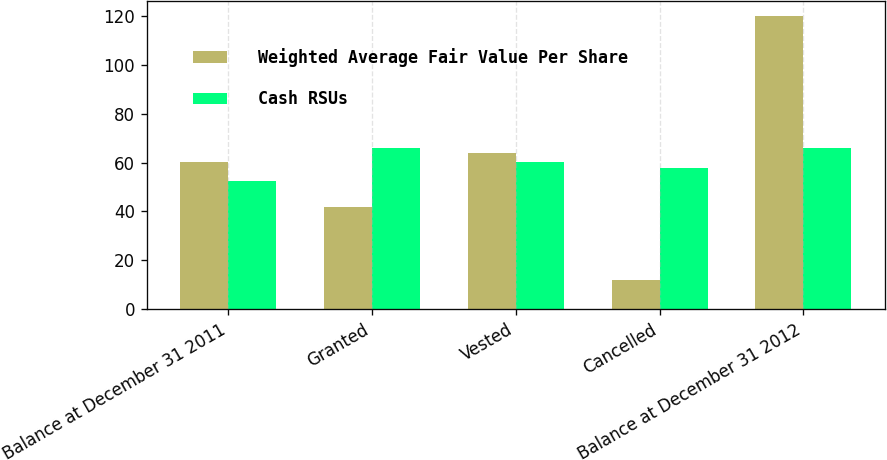Convert chart to OTSL. <chart><loc_0><loc_0><loc_500><loc_500><stacked_bar_chart><ecel><fcel>Balance at December 31 2011<fcel>Granted<fcel>Vested<fcel>Cancelled<fcel>Balance at December 31 2012<nl><fcel>Weighted Average Fair Value Per Share<fcel>60.21<fcel>42<fcel>64<fcel>12<fcel>120<nl><fcel>Cash RSUs<fcel>52.42<fcel>65.96<fcel>60.21<fcel>57.79<fcel>65.96<nl></chart> 